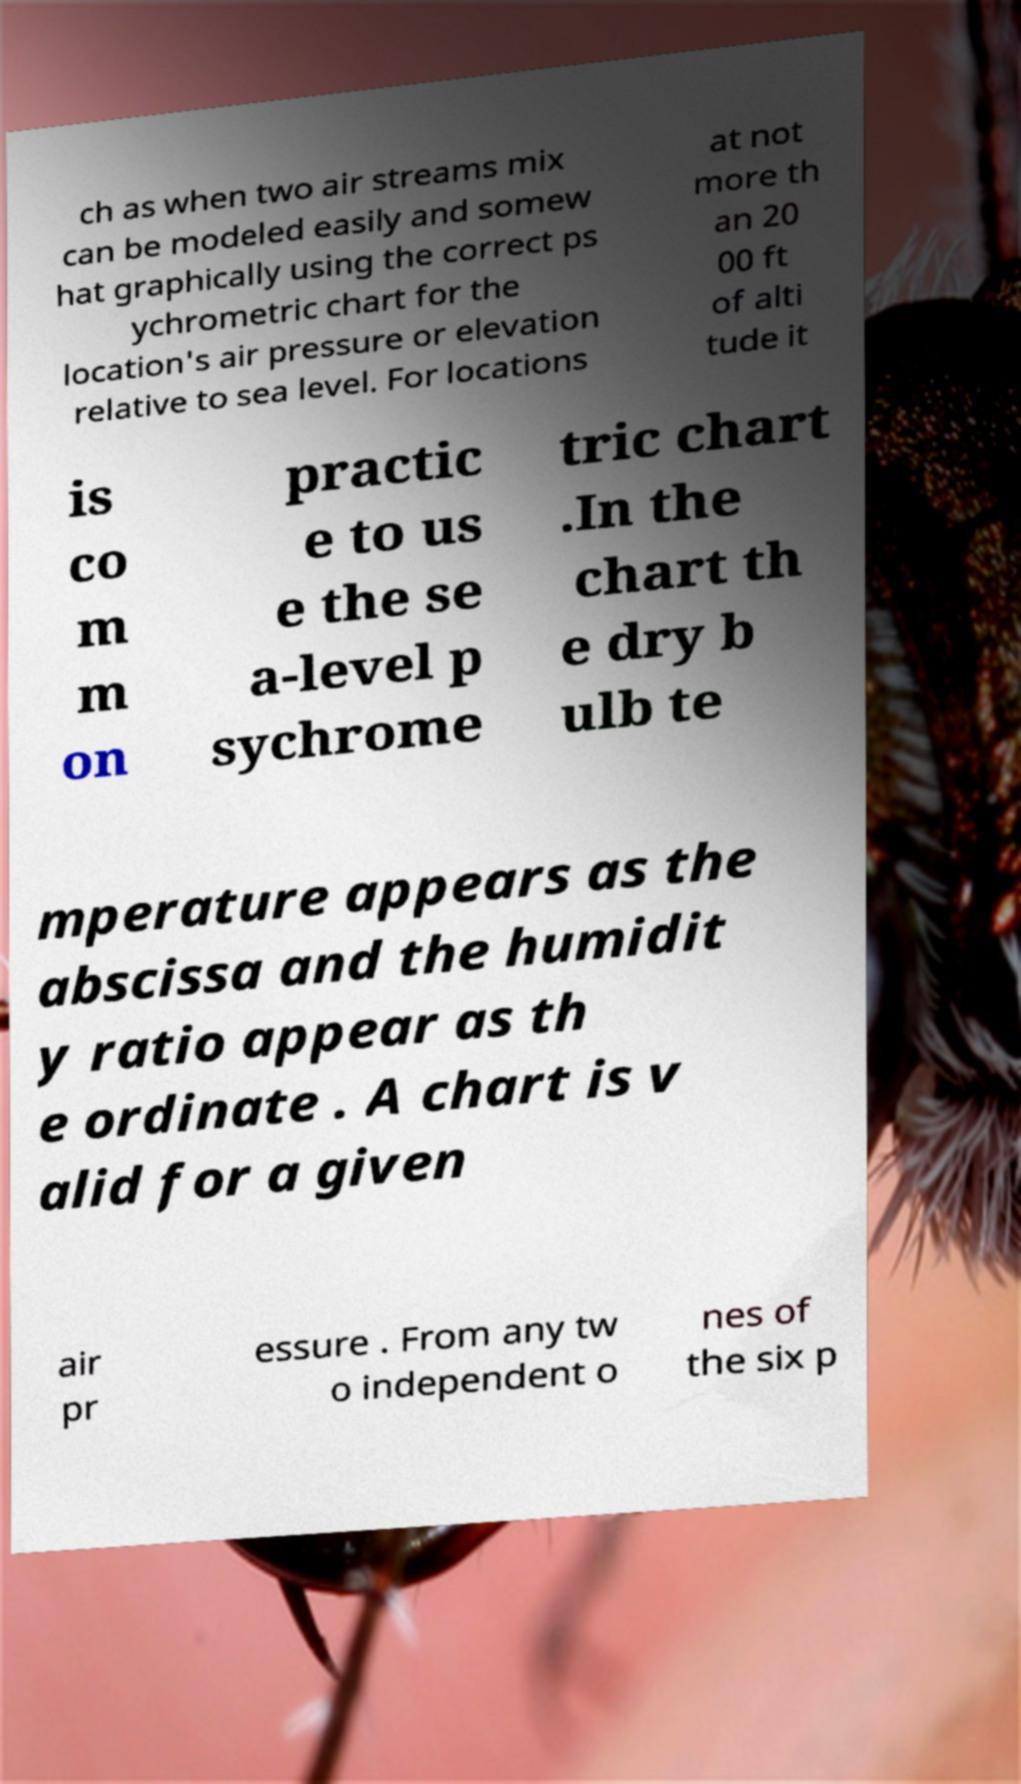Can you read and provide the text displayed in the image?This photo seems to have some interesting text. Can you extract and type it out for me? ch as when two air streams mix can be modeled easily and somew hat graphically using the correct ps ychrometric chart for the location's air pressure or elevation relative to sea level. For locations at not more th an 20 00 ft of alti tude it is co m m on practic e to us e the se a-level p sychrome tric chart .In the chart th e dry b ulb te mperature appears as the abscissa and the humidit y ratio appear as th e ordinate . A chart is v alid for a given air pr essure . From any tw o independent o nes of the six p 